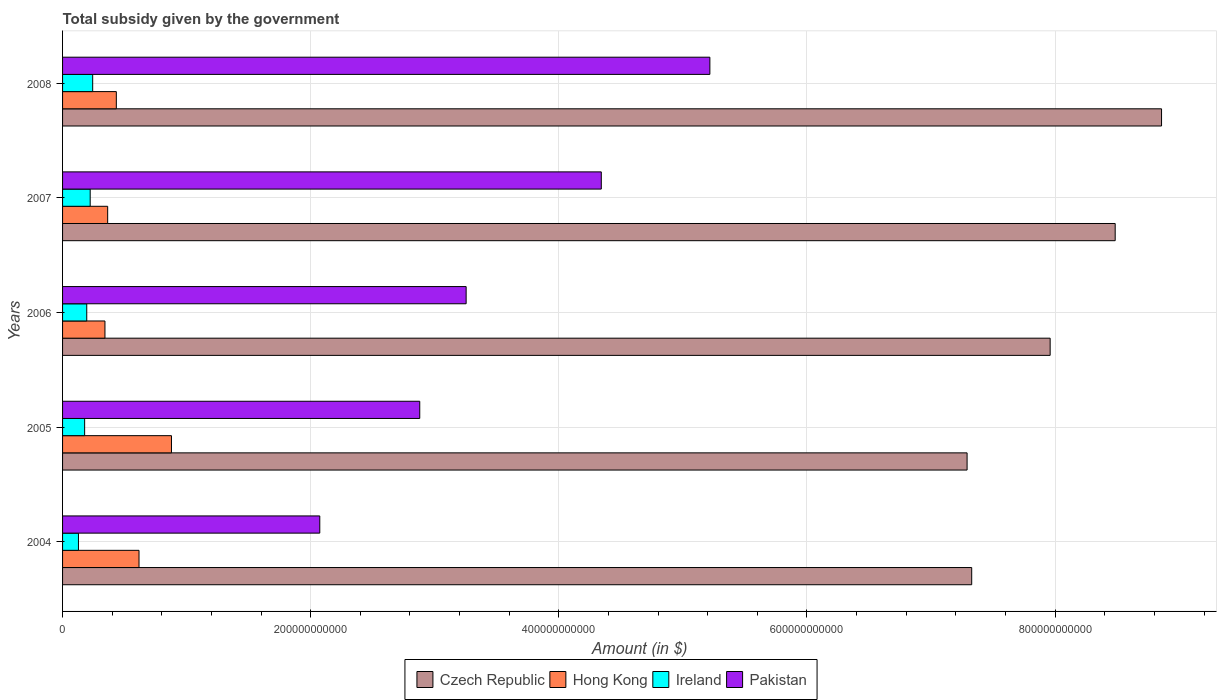Are the number of bars per tick equal to the number of legend labels?
Provide a succinct answer. Yes. Are the number of bars on each tick of the Y-axis equal?
Your answer should be very brief. Yes. What is the label of the 5th group of bars from the top?
Your answer should be compact. 2004. In how many cases, is the number of bars for a given year not equal to the number of legend labels?
Keep it short and to the point. 0. What is the total revenue collected by the government in Ireland in 2005?
Give a very brief answer. 1.78e+1. Across all years, what is the maximum total revenue collected by the government in Ireland?
Your response must be concise. 2.43e+1. Across all years, what is the minimum total revenue collected by the government in Hong Kong?
Keep it short and to the point. 3.42e+1. In which year was the total revenue collected by the government in Pakistan maximum?
Keep it short and to the point. 2008. What is the total total revenue collected by the government in Pakistan in the graph?
Your answer should be compact. 1.78e+12. What is the difference between the total revenue collected by the government in Pakistan in 2004 and that in 2007?
Your answer should be compact. -2.27e+11. What is the difference between the total revenue collected by the government in Hong Kong in 2004 and the total revenue collected by the government in Czech Republic in 2005?
Offer a very short reply. -6.67e+11. What is the average total revenue collected by the government in Pakistan per year?
Ensure brevity in your answer.  3.55e+11. In the year 2004, what is the difference between the total revenue collected by the government in Pakistan and total revenue collected by the government in Hong Kong?
Make the answer very short. 1.46e+11. In how many years, is the total revenue collected by the government in Czech Republic greater than 680000000000 $?
Provide a succinct answer. 5. What is the ratio of the total revenue collected by the government in Hong Kong in 2007 to that in 2008?
Ensure brevity in your answer.  0.84. Is the total revenue collected by the government in Pakistan in 2006 less than that in 2007?
Your response must be concise. Yes. Is the difference between the total revenue collected by the government in Pakistan in 2004 and 2006 greater than the difference between the total revenue collected by the government in Hong Kong in 2004 and 2006?
Make the answer very short. No. What is the difference between the highest and the second highest total revenue collected by the government in Czech Republic?
Give a very brief answer. 3.74e+1. What is the difference between the highest and the lowest total revenue collected by the government in Ireland?
Give a very brief answer. 1.15e+1. In how many years, is the total revenue collected by the government in Pakistan greater than the average total revenue collected by the government in Pakistan taken over all years?
Give a very brief answer. 2. Is it the case that in every year, the sum of the total revenue collected by the government in Hong Kong and total revenue collected by the government in Ireland is greater than the sum of total revenue collected by the government in Czech Republic and total revenue collected by the government in Pakistan?
Give a very brief answer. No. What does the 2nd bar from the top in 2004 represents?
Offer a very short reply. Ireland. What does the 4th bar from the bottom in 2006 represents?
Your answer should be compact. Pakistan. Are all the bars in the graph horizontal?
Give a very brief answer. Yes. What is the difference between two consecutive major ticks on the X-axis?
Ensure brevity in your answer.  2.00e+11. Are the values on the major ticks of X-axis written in scientific E-notation?
Your answer should be compact. No. Does the graph contain grids?
Ensure brevity in your answer.  Yes. How many legend labels are there?
Make the answer very short. 4. How are the legend labels stacked?
Your answer should be very brief. Horizontal. What is the title of the graph?
Keep it short and to the point. Total subsidy given by the government. Does "Djibouti" appear as one of the legend labels in the graph?
Keep it short and to the point. No. What is the label or title of the X-axis?
Ensure brevity in your answer.  Amount (in $). What is the label or title of the Y-axis?
Provide a succinct answer. Years. What is the Amount (in $) of Czech Republic in 2004?
Offer a terse response. 7.33e+11. What is the Amount (in $) in Hong Kong in 2004?
Make the answer very short. 6.16e+1. What is the Amount (in $) of Ireland in 2004?
Make the answer very short. 1.28e+1. What is the Amount (in $) of Pakistan in 2004?
Offer a very short reply. 2.07e+11. What is the Amount (in $) in Czech Republic in 2005?
Offer a very short reply. 7.29e+11. What is the Amount (in $) in Hong Kong in 2005?
Provide a short and direct response. 8.78e+1. What is the Amount (in $) in Ireland in 2005?
Your response must be concise. 1.78e+1. What is the Amount (in $) of Pakistan in 2005?
Your answer should be very brief. 2.88e+11. What is the Amount (in $) in Czech Republic in 2006?
Your answer should be very brief. 7.96e+11. What is the Amount (in $) in Hong Kong in 2006?
Your response must be concise. 3.42e+1. What is the Amount (in $) of Ireland in 2006?
Offer a terse response. 1.95e+1. What is the Amount (in $) of Pakistan in 2006?
Offer a very short reply. 3.25e+11. What is the Amount (in $) in Czech Republic in 2007?
Your answer should be very brief. 8.48e+11. What is the Amount (in $) in Hong Kong in 2007?
Your response must be concise. 3.64e+1. What is the Amount (in $) in Ireland in 2007?
Your response must be concise. 2.23e+1. What is the Amount (in $) in Pakistan in 2007?
Provide a succinct answer. 4.34e+11. What is the Amount (in $) in Czech Republic in 2008?
Your answer should be compact. 8.86e+11. What is the Amount (in $) of Hong Kong in 2008?
Make the answer very short. 4.33e+1. What is the Amount (in $) of Ireland in 2008?
Make the answer very short. 2.43e+1. What is the Amount (in $) in Pakistan in 2008?
Keep it short and to the point. 5.22e+11. Across all years, what is the maximum Amount (in $) of Czech Republic?
Provide a succinct answer. 8.86e+11. Across all years, what is the maximum Amount (in $) in Hong Kong?
Your response must be concise. 8.78e+1. Across all years, what is the maximum Amount (in $) in Ireland?
Your answer should be very brief. 2.43e+1. Across all years, what is the maximum Amount (in $) of Pakistan?
Offer a terse response. 5.22e+11. Across all years, what is the minimum Amount (in $) in Czech Republic?
Ensure brevity in your answer.  7.29e+11. Across all years, what is the minimum Amount (in $) of Hong Kong?
Offer a terse response. 3.42e+1. Across all years, what is the minimum Amount (in $) of Ireland?
Offer a very short reply. 1.28e+1. Across all years, what is the minimum Amount (in $) of Pakistan?
Offer a terse response. 2.07e+11. What is the total Amount (in $) in Czech Republic in the graph?
Offer a terse response. 3.99e+12. What is the total Amount (in $) of Hong Kong in the graph?
Provide a short and direct response. 2.63e+11. What is the total Amount (in $) of Ireland in the graph?
Offer a very short reply. 9.66e+1. What is the total Amount (in $) in Pakistan in the graph?
Provide a short and direct response. 1.78e+12. What is the difference between the Amount (in $) of Czech Republic in 2004 and that in 2005?
Your response must be concise. 3.72e+09. What is the difference between the Amount (in $) of Hong Kong in 2004 and that in 2005?
Your answer should be compact. -2.62e+1. What is the difference between the Amount (in $) in Ireland in 2004 and that in 2005?
Ensure brevity in your answer.  -5.00e+09. What is the difference between the Amount (in $) of Pakistan in 2004 and that in 2005?
Provide a short and direct response. -8.06e+1. What is the difference between the Amount (in $) of Czech Republic in 2004 and that in 2006?
Provide a short and direct response. -6.32e+1. What is the difference between the Amount (in $) of Hong Kong in 2004 and that in 2006?
Your response must be concise. 2.75e+1. What is the difference between the Amount (in $) of Ireland in 2004 and that in 2006?
Provide a succinct answer. -6.69e+09. What is the difference between the Amount (in $) of Pakistan in 2004 and that in 2006?
Provide a short and direct response. -1.18e+11. What is the difference between the Amount (in $) in Czech Republic in 2004 and that in 2007?
Your response must be concise. -1.16e+11. What is the difference between the Amount (in $) in Hong Kong in 2004 and that in 2007?
Provide a succinct answer. 2.53e+1. What is the difference between the Amount (in $) of Ireland in 2004 and that in 2007?
Offer a very short reply. -9.47e+09. What is the difference between the Amount (in $) of Pakistan in 2004 and that in 2007?
Provide a succinct answer. -2.27e+11. What is the difference between the Amount (in $) in Czech Republic in 2004 and that in 2008?
Provide a short and direct response. -1.53e+11. What is the difference between the Amount (in $) of Hong Kong in 2004 and that in 2008?
Your response must be concise. 1.83e+1. What is the difference between the Amount (in $) in Ireland in 2004 and that in 2008?
Your answer should be very brief. -1.15e+1. What is the difference between the Amount (in $) of Pakistan in 2004 and that in 2008?
Give a very brief answer. -3.14e+11. What is the difference between the Amount (in $) in Czech Republic in 2005 and that in 2006?
Offer a very short reply. -6.70e+1. What is the difference between the Amount (in $) in Hong Kong in 2005 and that in 2006?
Provide a short and direct response. 5.36e+1. What is the difference between the Amount (in $) of Ireland in 2005 and that in 2006?
Provide a succinct answer. -1.69e+09. What is the difference between the Amount (in $) in Pakistan in 2005 and that in 2006?
Provide a succinct answer. -3.74e+1. What is the difference between the Amount (in $) of Czech Republic in 2005 and that in 2007?
Offer a very short reply. -1.19e+11. What is the difference between the Amount (in $) of Hong Kong in 2005 and that in 2007?
Offer a terse response. 5.14e+1. What is the difference between the Amount (in $) in Ireland in 2005 and that in 2007?
Offer a very short reply. -4.47e+09. What is the difference between the Amount (in $) of Pakistan in 2005 and that in 2007?
Keep it short and to the point. -1.46e+11. What is the difference between the Amount (in $) in Czech Republic in 2005 and that in 2008?
Keep it short and to the point. -1.57e+11. What is the difference between the Amount (in $) in Hong Kong in 2005 and that in 2008?
Your response must be concise. 4.44e+1. What is the difference between the Amount (in $) in Ireland in 2005 and that in 2008?
Your response must be concise. -6.48e+09. What is the difference between the Amount (in $) of Pakistan in 2005 and that in 2008?
Offer a very short reply. -2.34e+11. What is the difference between the Amount (in $) in Czech Republic in 2006 and that in 2007?
Give a very brief answer. -5.24e+1. What is the difference between the Amount (in $) of Hong Kong in 2006 and that in 2007?
Give a very brief answer. -2.20e+09. What is the difference between the Amount (in $) in Ireland in 2006 and that in 2007?
Make the answer very short. -2.78e+09. What is the difference between the Amount (in $) of Pakistan in 2006 and that in 2007?
Offer a terse response. -1.09e+11. What is the difference between the Amount (in $) in Czech Republic in 2006 and that in 2008?
Give a very brief answer. -8.98e+1. What is the difference between the Amount (in $) of Hong Kong in 2006 and that in 2008?
Your response must be concise. -9.17e+09. What is the difference between the Amount (in $) of Ireland in 2006 and that in 2008?
Offer a terse response. -4.79e+09. What is the difference between the Amount (in $) of Pakistan in 2006 and that in 2008?
Give a very brief answer. -1.96e+11. What is the difference between the Amount (in $) of Czech Republic in 2007 and that in 2008?
Make the answer very short. -3.74e+1. What is the difference between the Amount (in $) of Hong Kong in 2007 and that in 2008?
Your response must be concise. -6.98e+09. What is the difference between the Amount (in $) of Ireland in 2007 and that in 2008?
Your response must be concise. -2.01e+09. What is the difference between the Amount (in $) of Pakistan in 2007 and that in 2008?
Your answer should be very brief. -8.75e+1. What is the difference between the Amount (in $) in Czech Republic in 2004 and the Amount (in $) in Hong Kong in 2005?
Offer a terse response. 6.45e+11. What is the difference between the Amount (in $) in Czech Republic in 2004 and the Amount (in $) in Ireland in 2005?
Provide a succinct answer. 7.15e+11. What is the difference between the Amount (in $) in Czech Republic in 2004 and the Amount (in $) in Pakistan in 2005?
Offer a very short reply. 4.45e+11. What is the difference between the Amount (in $) of Hong Kong in 2004 and the Amount (in $) of Ireland in 2005?
Make the answer very short. 4.38e+1. What is the difference between the Amount (in $) of Hong Kong in 2004 and the Amount (in $) of Pakistan in 2005?
Provide a short and direct response. -2.26e+11. What is the difference between the Amount (in $) in Ireland in 2004 and the Amount (in $) in Pakistan in 2005?
Provide a succinct answer. -2.75e+11. What is the difference between the Amount (in $) of Czech Republic in 2004 and the Amount (in $) of Hong Kong in 2006?
Provide a short and direct response. 6.99e+11. What is the difference between the Amount (in $) in Czech Republic in 2004 and the Amount (in $) in Ireland in 2006?
Offer a terse response. 7.13e+11. What is the difference between the Amount (in $) of Czech Republic in 2004 and the Amount (in $) of Pakistan in 2006?
Make the answer very short. 4.07e+11. What is the difference between the Amount (in $) in Hong Kong in 2004 and the Amount (in $) in Ireland in 2006?
Give a very brief answer. 4.21e+1. What is the difference between the Amount (in $) in Hong Kong in 2004 and the Amount (in $) in Pakistan in 2006?
Ensure brevity in your answer.  -2.64e+11. What is the difference between the Amount (in $) in Ireland in 2004 and the Amount (in $) in Pakistan in 2006?
Ensure brevity in your answer.  -3.12e+11. What is the difference between the Amount (in $) in Czech Republic in 2004 and the Amount (in $) in Hong Kong in 2007?
Provide a short and direct response. 6.96e+11. What is the difference between the Amount (in $) of Czech Republic in 2004 and the Amount (in $) of Ireland in 2007?
Your answer should be compact. 7.10e+11. What is the difference between the Amount (in $) of Czech Republic in 2004 and the Amount (in $) of Pakistan in 2007?
Provide a short and direct response. 2.99e+11. What is the difference between the Amount (in $) in Hong Kong in 2004 and the Amount (in $) in Ireland in 2007?
Ensure brevity in your answer.  3.94e+1. What is the difference between the Amount (in $) of Hong Kong in 2004 and the Amount (in $) of Pakistan in 2007?
Keep it short and to the point. -3.73e+11. What is the difference between the Amount (in $) in Ireland in 2004 and the Amount (in $) in Pakistan in 2007?
Keep it short and to the point. -4.21e+11. What is the difference between the Amount (in $) of Czech Republic in 2004 and the Amount (in $) of Hong Kong in 2008?
Ensure brevity in your answer.  6.89e+11. What is the difference between the Amount (in $) in Czech Republic in 2004 and the Amount (in $) in Ireland in 2008?
Your answer should be compact. 7.08e+11. What is the difference between the Amount (in $) of Czech Republic in 2004 and the Amount (in $) of Pakistan in 2008?
Ensure brevity in your answer.  2.11e+11. What is the difference between the Amount (in $) of Hong Kong in 2004 and the Amount (in $) of Ireland in 2008?
Make the answer very short. 3.73e+1. What is the difference between the Amount (in $) of Hong Kong in 2004 and the Amount (in $) of Pakistan in 2008?
Give a very brief answer. -4.60e+11. What is the difference between the Amount (in $) of Ireland in 2004 and the Amount (in $) of Pakistan in 2008?
Provide a succinct answer. -5.09e+11. What is the difference between the Amount (in $) of Czech Republic in 2005 and the Amount (in $) of Hong Kong in 2006?
Make the answer very short. 6.95e+11. What is the difference between the Amount (in $) in Czech Republic in 2005 and the Amount (in $) in Ireland in 2006?
Offer a terse response. 7.10e+11. What is the difference between the Amount (in $) in Czech Republic in 2005 and the Amount (in $) in Pakistan in 2006?
Make the answer very short. 4.04e+11. What is the difference between the Amount (in $) in Hong Kong in 2005 and the Amount (in $) in Ireland in 2006?
Provide a short and direct response. 6.83e+1. What is the difference between the Amount (in $) of Hong Kong in 2005 and the Amount (in $) of Pakistan in 2006?
Your answer should be compact. -2.38e+11. What is the difference between the Amount (in $) in Ireland in 2005 and the Amount (in $) in Pakistan in 2006?
Give a very brief answer. -3.07e+11. What is the difference between the Amount (in $) of Czech Republic in 2005 and the Amount (in $) of Hong Kong in 2007?
Keep it short and to the point. 6.93e+11. What is the difference between the Amount (in $) in Czech Republic in 2005 and the Amount (in $) in Ireland in 2007?
Give a very brief answer. 7.07e+11. What is the difference between the Amount (in $) in Czech Republic in 2005 and the Amount (in $) in Pakistan in 2007?
Provide a short and direct response. 2.95e+11. What is the difference between the Amount (in $) in Hong Kong in 2005 and the Amount (in $) in Ireland in 2007?
Offer a very short reply. 6.55e+1. What is the difference between the Amount (in $) in Hong Kong in 2005 and the Amount (in $) in Pakistan in 2007?
Offer a very short reply. -3.46e+11. What is the difference between the Amount (in $) in Ireland in 2005 and the Amount (in $) in Pakistan in 2007?
Offer a very short reply. -4.16e+11. What is the difference between the Amount (in $) of Czech Republic in 2005 and the Amount (in $) of Hong Kong in 2008?
Provide a succinct answer. 6.86e+11. What is the difference between the Amount (in $) of Czech Republic in 2005 and the Amount (in $) of Ireland in 2008?
Make the answer very short. 7.05e+11. What is the difference between the Amount (in $) in Czech Republic in 2005 and the Amount (in $) in Pakistan in 2008?
Offer a very short reply. 2.07e+11. What is the difference between the Amount (in $) of Hong Kong in 2005 and the Amount (in $) of Ireland in 2008?
Make the answer very short. 6.35e+1. What is the difference between the Amount (in $) of Hong Kong in 2005 and the Amount (in $) of Pakistan in 2008?
Offer a terse response. -4.34e+11. What is the difference between the Amount (in $) of Ireland in 2005 and the Amount (in $) of Pakistan in 2008?
Your response must be concise. -5.04e+11. What is the difference between the Amount (in $) in Czech Republic in 2006 and the Amount (in $) in Hong Kong in 2007?
Provide a succinct answer. 7.60e+11. What is the difference between the Amount (in $) of Czech Republic in 2006 and the Amount (in $) of Ireland in 2007?
Ensure brevity in your answer.  7.74e+11. What is the difference between the Amount (in $) of Czech Republic in 2006 and the Amount (in $) of Pakistan in 2007?
Your answer should be compact. 3.62e+11. What is the difference between the Amount (in $) of Hong Kong in 2006 and the Amount (in $) of Ireland in 2007?
Give a very brief answer. 1.19e+1. What is the difference between the Amount (in $) of Hong Kong in 2006 and the Amount (in $) of Pakistan in 2007?
Provide a short and direct response. -4.00e+11. What is the difference between the Amount (in $) of Ireland in 2006 and the Amount (in $) of Pakistan in 2007?
Offer a very short reply. -4.15e+11. What is the difference between the Amount (in $) in Czech Republic in 2006 and the Amount (in $) in Hong Kong in 2008?
Make the answer very short. 7.53e+11. What is the difference between the Amount (in $) in Czech Republic in 2006 and the Amount (in $) in Ireland in 2008?
Make the answer very short. 7.72e+11. What is the difference between the Amount (in $) of Czech Republic in 2006 and the Amount (in $) of Pakistan in 2008?
Your answer should be very brief. 2.74e+11. What is the difference between the Amount (in $) of Hong Kong in 2006 and the Amount (in $) of Ireland in 2008?
Your answer should be very brief. 9.88e+09. What is the difference between the Amount (in $) of Hong Kong in 2006 and the Amount (in $) of Pakistan in 2008?
Ensure brevity in your answer.  -4.88e+11. What is the difference between the Amount (in $) of Ireland in 2006 and the Amount (in $) of Pakistan in 2008?
Ensure brevity in your answer.  -5.02e+11. What is the difference between the Amount (in $) of Czech Republic in 2007 and the Amount (in $) of Hong Kong in 2008?
Ensure brevity in your answer.  8.05e+11. What is the difference between the Amount (in $) of Czech Republic in 2007 and the Amount (in $) of Ireland in 2008?
Provide a short and direct response. 8.24e+11. What is the difference between the Amount (in $) in Czech Republic in 2007 and the Amount (in $) in Pakistan in 2008?
Provide a short and direct response. 3.27e+11. What is the difference between the Amount (in $) in Hong Kong in 2007 and the Amount (in $) in Ireland in 2008?
Give a very brief answer. 1.21e+1. What is the difference between the Amount (in $) of Hong Kong in 2007 and the Amount (in $) of Pakistan in 2008?
Make the answer very short. -4.85e+11. What is the difference between the Amount (in $) of Ireland in 2007 and the Amount (in $) of Pakistan in 2008?
Give a very brief answer. -4.99e+11. What is the average Amount (in $) in Czech Republic per year?
Provide a succinct answer. 7.98e+11. What is the average Amount (in $) of Hong Kong per year?
Your answer should be very brief. 5.26e+1. What is the average Amount (in $) of Ireland per year?
Offer a terse response. 1.93e+1. What is the average Amount (in $) of Pakistan per year?
Give a very brief answer. 3.55e+11. In the year 2004, what is the difference between the Amount (in $) of Czech Republic and Amount (in $) of Hong Kong?
Offer a terse response. 6.71e+11. In the year 2004, what is the difference between the Amount (in $) of Czech Republic and Amount (in $) of Ireland?
Ensure brevity in your answer.  7.20e+11. In the year 2004, what is the difference between the Amount (in $) of Czech Republic and Amount (in $) of Pakistan?
Your answer should be compact. 5.25e+11. In the year 2004, what is the difference between the Amount (in $) of Hong Kong and Amount (in $) of Ireland?
Keep it short and to the point. 4.88e+1. In the year 2004, what is the difference between the Amount (in $) in Hong Kong and Amount (in $) in Pakistan?
Ensure brevity in your answer.  -1.46e+11. In the year 2004, what is the difference between the Amount (in $) in Ireland and Amount (in $) in Pakistan?
Keep it short and to the point. -1.95e+11. In the year 2005, what is the difference between the Amount (in $) in Czech Republic and Amount (in $) in Hong Kong?
Your answer should be compact. 6.41e+11. In the year 2005, what is the difference between the Amount (in $) of Czech Republic and Amount (in $) of Ireland?
Give a very brief answer. 7.11e+11. In the year 2005, what is the difference between the Amount (in $) in Czech Republic and Amount (in $) in Pakistan?
Make the answer very short. 4.41e+11. In the year 2005, what is the difference between the Amount (in $) of Hong Kong and Amount (in $) of Ireland?
Make the answer very short. 7.00e+1. In the year 2005, what is the difference between the Amount (in $) in Hong Kong and Amount (in $) in Pakistan?
Provide a succinct answer. -2.00e+11. In the year 2005, what is the difference between the Amount (in $) of Ireland and Amount (in $) of Pakistan?
Your response must be concise. -2.70e+11. In the year 2006, what is the difference between the Amount (in $) in Czech Republic and Amount (in $) in Hong Kong?
Make the answer very short. 7.62e+11. In the year 2006, what is the difference between the Amount (in $) of Czech Republic and Amount (in $) of Ireland?
Provide a short and direct response. 7.77e+11. In the year 2006, what is the difference between the Amount (in $) in Czech Republic and Amount (in $) in Pakistan?
Offer a terse response. 4.71e+11. In the year 2006, what is the difference between the Amount (in $) in Hong Kong and Amount (in $) in Ireland?
Provide a short and direct response. 1.47e+1. In the year 2006, what is the difference between the Amount (in $) in Hong Kong and Amount (in $) in Pakistan?
Your response must be concise. -2.91e+11. In the year 2006, what is the difference between the Amount (in $) of Ireland and Amount (in $) of Pakistan?
Keep it short and to the point. -3.06e+11. In the year 2007, what is the difference between the Amount (in $) of Czech Republic and Amount (in $) of Hong Kong?
Your answer should be very brief. 8.12e+11. In the year 2007, what is the difference between the Amount (in $) of Czech Republic and Amount (in $) of Ireland?
Provide a succinct answer. 8.26e+11. In the year 2007, what is the difference between the Amount (in $) of Czech Republic and Amount (in $) of Pakistan?
Your answer should be compact. 4.14e+11. In the year 2007, what is the difference between the Amount (in $) in Hong Kong and Amount (in $) in Ireland?
Keep it short and to the point. 1.41e+1. In the year 2007, what is the difference between the Amount (in $) of Hong Kong and Amount (in $) of Pakistan?
Give a very brief answer. -3.98e+11. In the year 2007, what is the difference between the Amount (in $) of Ireland and Amount (in $) of Pakistan?
Your answer should be very brief. -4.12e+11. In the year 2008, what is the difference between the Amount (in $) of Czech Republic and Amount (in $) of Hong Kong?
Provide a succinct answer. 8.42e+11. In the year 2008, what is the difference between the Amount (in $) of Czech Republic and Amount (in $) of Ireland?
Your response must be concise. 8.61e+11. In the year 2008, what is the difference between the Amount (in $) of Czech Republic and Amount (in $) of Pakistan?
Offer a terse response. 3.64e+11. In the year 2008, what is the difference between the Amount (in $) in Hong Kong and Amount (in $) in Ireland?
Your answer should be compact. 1.91e+1. In the year 2008, what is the difference between the Amount (in $) in Hong Kong and Amount (in $) in Pakistan?
Provide a short and direct response. -4.78e+11. In the year 2008, what is the difference between the Amount (in $) of Ireland and Amount (in $) of Pakistan?
Your response must be concise. -4.97e+11. What is the ratio of the Amount (in $) of Czech Republic in 2004 to that in 2005?
Your answer should be compact. 1.01. What is the ratio of the Amount (in $) in Hong Kong in 2004 to that in 2005?
Ensure brevity in your answer.  0.7. What is the ratio of the Amount (in $) in Ireland in 2004 to that in 2005?
Offer a terse response. 0.72. What is the ratio of the Amount (in $) in Pakistan in 2004 to that in 2005?
Give a very brief answer. 0.72. What is the ratio of the Amount (in $) of Czech Republic in 2004 to that in 2006?
Offer a terse response. 0.92. What is the ratio of the Amount (in $) of Hong Kong in 2004 to that in 2006?
Provide a succinct answer. 1.8. What is the ratio of the Amount (in $) of Ireland in 2004 to that in 2006?
Give a very brief answer. 0.66. What is the ratio of the Amount (in $) in Pakistan in 2004 to that in 2006?
Keep it short and to the point. 0.64. What is the ratio of the Amount (in $) of Czech Republic in 2004 to that in 2007?
Provide a short and direct response. 0.86. What is the ratio of the Amount (in $) of Hong Kong in 2004 to that in 2007?
Your answer should be very brief. 1.7. What is the ratio of the Amount (in $) in Ireland in 2004 to that in 2007?
Your response must be concise. 0.57. What is the ratio of the Amount (in $) of Pakistan in 2004 to that in 2007?
Offer a terse response. 0.48. What is the ratio of the Amount (in $) in Czech Republic in 2004 to that in 2008?
Your response must be concise. 0.83. What is the ratio of the Amount (in $) in Hong Kong in 2004 to that in 2008?
Provide a short and direct response. 1.42. What is the ratio of the Amount (in $) in Ireland in 2004 to that in 2008?
Your response must be concise. 0.53. What is the ratio of the Amount (in $) in Pakistan in 2004 to that in 2008?
Offer a very short reply. 0.4. What is the ratio of the Amount (in $) of Czech Republic in 2005 to that in 2006?
Your response must be concise. 0.92. What is the ratio of the Amount (in $) in Hong Kong in 2005 to that in 2006?
Keep it short and to the point. 2.57. What is the ratio of the Amount (in $) in Ireland in 2005 to that in 2006?
Your answer should be very brief. 0.91. What is the ratio of the Amount (in $) in Pakistan in 2005 to that in 2006?
Make the answer very short. 0.89. What is the ratio of the Amount (in $) in Czech Republic in 2005 to that in 2007?
Ensure brevity in your answer.  0.86. What is the ratio of the Amount (in $) of Hong Kong in 2005 to that in 2007?
Your response must be concise. 2.41. What is the ratio of the Amount (in $) in Ireland in 2005 to that in 2007?
Keep it short and to the point. 0.8. What is the ratio of the Amount (in $) of Pakistan in 2005 to that in 2007?
Provide a short and direct response. 0.66. What is the ratio of the Amount (in $) in Czech Republic in 2005 to that in 2008?
Your answer should be compact. 0.82. What is the ratio of the Amount (in $) in Hong Kong in 2005 to that in 2008?
Give a very brief answer. 2.03. What is the ratio of the Amount (in $) of Ireland in 2005 to that in 2008?
Give a very brief answer. 0.73. What is the ratio of the Amount (in $) of Pakistan in 2005 to that in 2008?
Provide a short and direct response. 0.55. What is the ratio of the Amount (in $) in Czech Republic in 2006 to that in 2007?
Your answer should be very brief. 0.94. What is the ratio of the Amount (in $) of Hong Kong in 2006 to that in 2007?
Provide a succinct answer. 0.94. What is the ratio of the Amount (in $) of Ireland in 2006 to that in 2007?
Give a very brief answer. 0.88. What is the ratio of the Amount (in $) of Pakistan in 2006 to that in 2007?
Offer a very short reply. 0.75. What is the ratio of the Amount (in $) in Czech Republic in 2006 to that in 2008?
Provide a succinct answer. 0.9. What is the ratio of the Amount (in $) in Hong Kong in 2006 to that in 2008?
Keep it short and to the point. 0.79. What is the ratio of the Amount (in $) of Ireland in 2006 to that in 2008?
Keep it short and to the point. 0.8. What is the ratio of the Amount (in $) of Pakistan in 2006 to that in 2008?
Your answer should be very brief. 0.62. What is the ratio of the Amount (in $) of Czech Republic in 2007 to that in 2008?
Your answer should be very brief. 0.96. What is the ratio of the Amount (in $) of Hong Kong in 2007 to that in 2008?
Give a very brief answer. 0.84. What is the ratio of the Amount (in $) of Ireland in 2007 to that in 2008?
Offer a terse response. 0.92. What is the ratio of the Amount (in $) of Pakistan in 2007 to that in 2008?
Keep it short and to the point. 0.83. What is the difference between the highest and the second highest Amount (in $) in Czech Republic?
Provide a short and direct response. 3.74e+1. What is the difference between the highest and the second highest Amount (in $) in Hong Kong?
Your answer should be very brief. 2.62e+1. What is the difference between the highest and the second highest Amount (in $) of Ireland?
Your answer should be compact. 2.01e+09. What is the difference between the highest and the second highest Amount (in $) in Pakistan?
Provide a short and direct response. 8.75e+1. What is the difference between the highest and the lowest Amount (in $) of Czech Republic?
Your response must be concise. 1.57e+11. What is the difference between the highest and the lowest Amount (in $) in Hong Kong?
Keep it short and to the point. 5.36e+1. What is the difference between the highest and the lowest Amount (in $) in Ireland?
Provide a succinct answer. 1.15e+1. What is the difference between the highest and the lowest Amount (in $) of Pakistan?
Ensure brevity in your answer.  3.14e+11. 